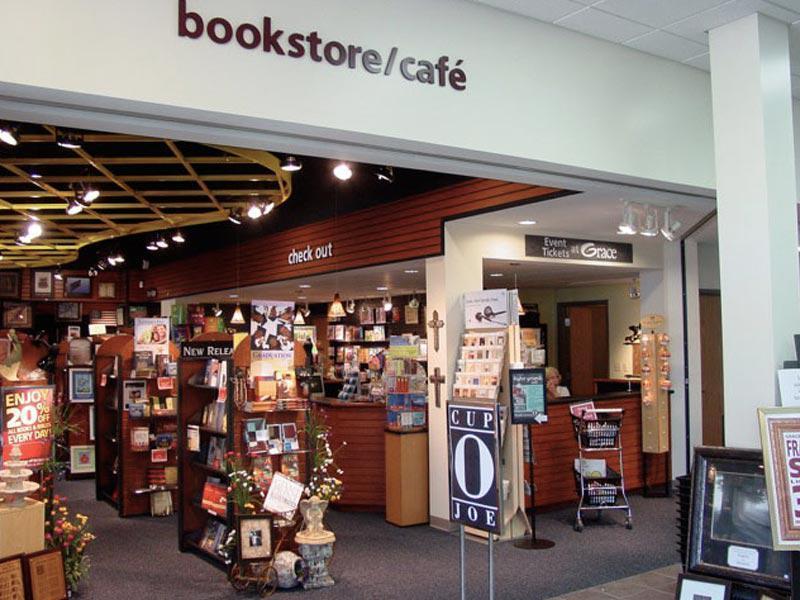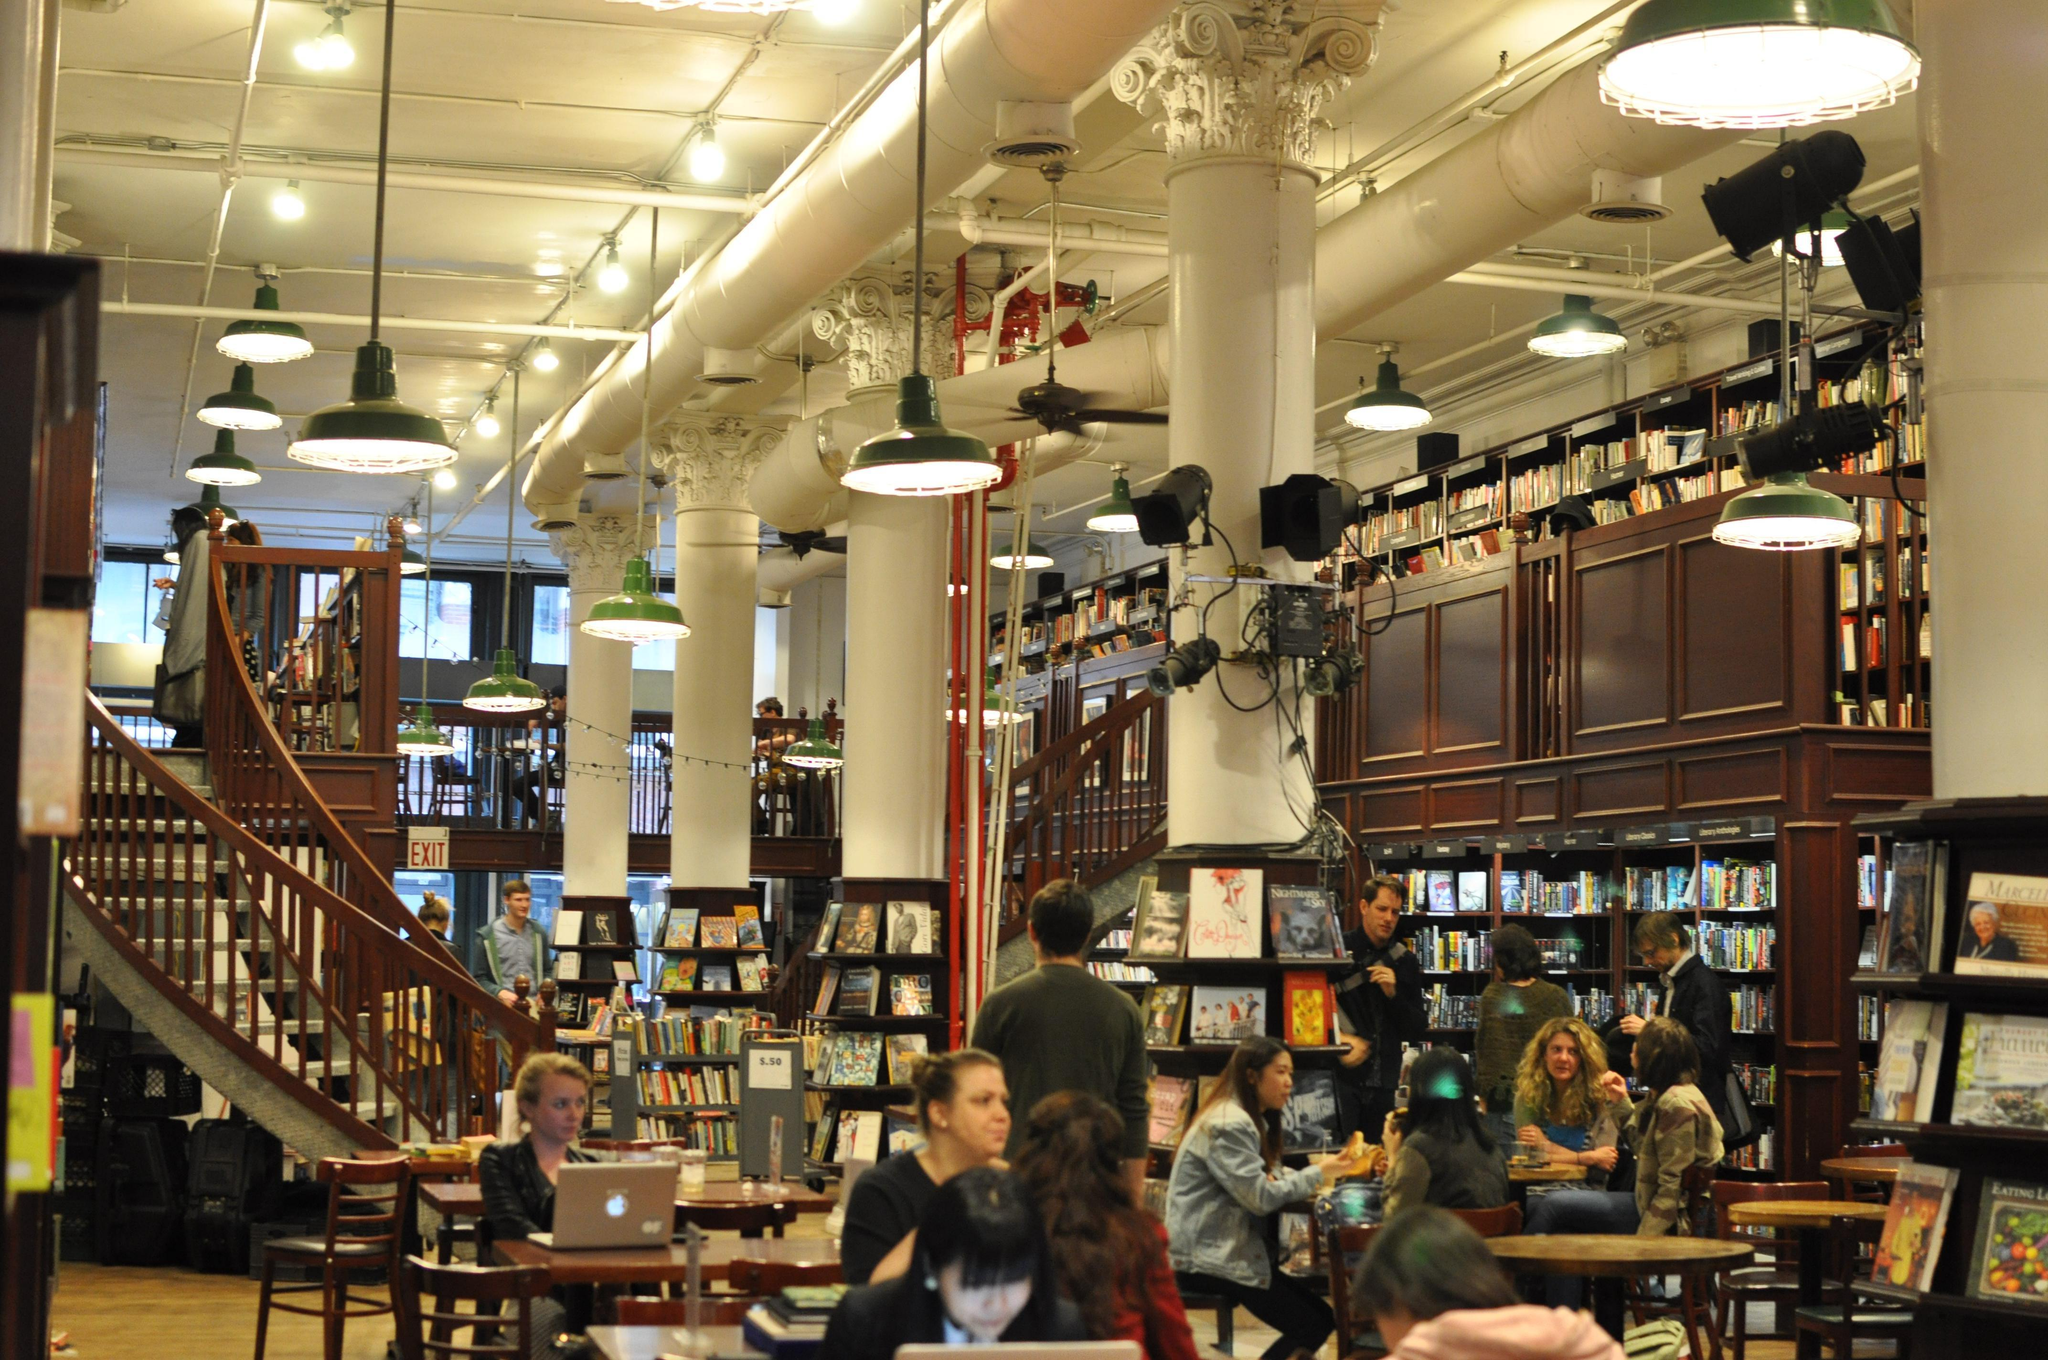The first image is the image on the left, the second image is the image on the right. For the images shown, is this caption "The front of the bookstore is painted green." true? Answer yes or no. No. The first image is the image on the left, the second image is the image on the right. Considering the images on both sides, is "A bookstore has a curved staircase that leads to a higher floor." valid? Answer yes or no. Yes. 